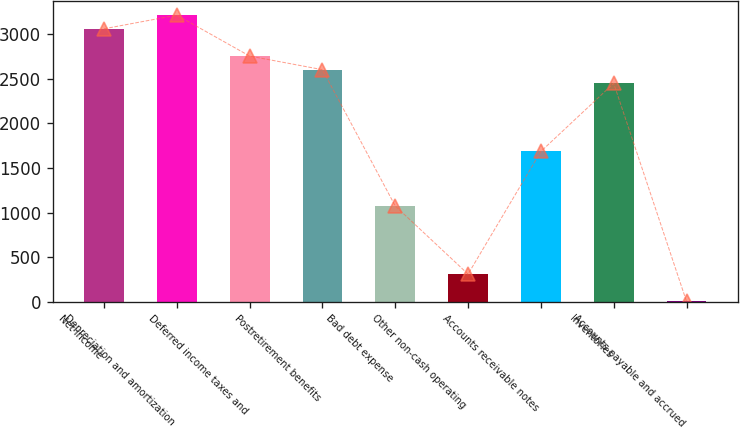<chart> <loc_0><loc_0><loc_500><loc_500><bar_chart><fcel>Net income<fcel>Depreciation and amortization<fcel>Deferred income taxes and<fcel>Postretirement benefits<fcel>Bad debt expense<fcel>Other non-cash operating<fcel>Accounts receivable notes<fcel>Inventories<fcel>Accounts payable and accrued<nl><fcel>3060<fcel>3212.8<fcel>2754.4<fcel>2601.6<fcel>1073.6<fcel>309.6<fcel>1684.8<fcel>2448.8<fcel>4<nl></chart> 